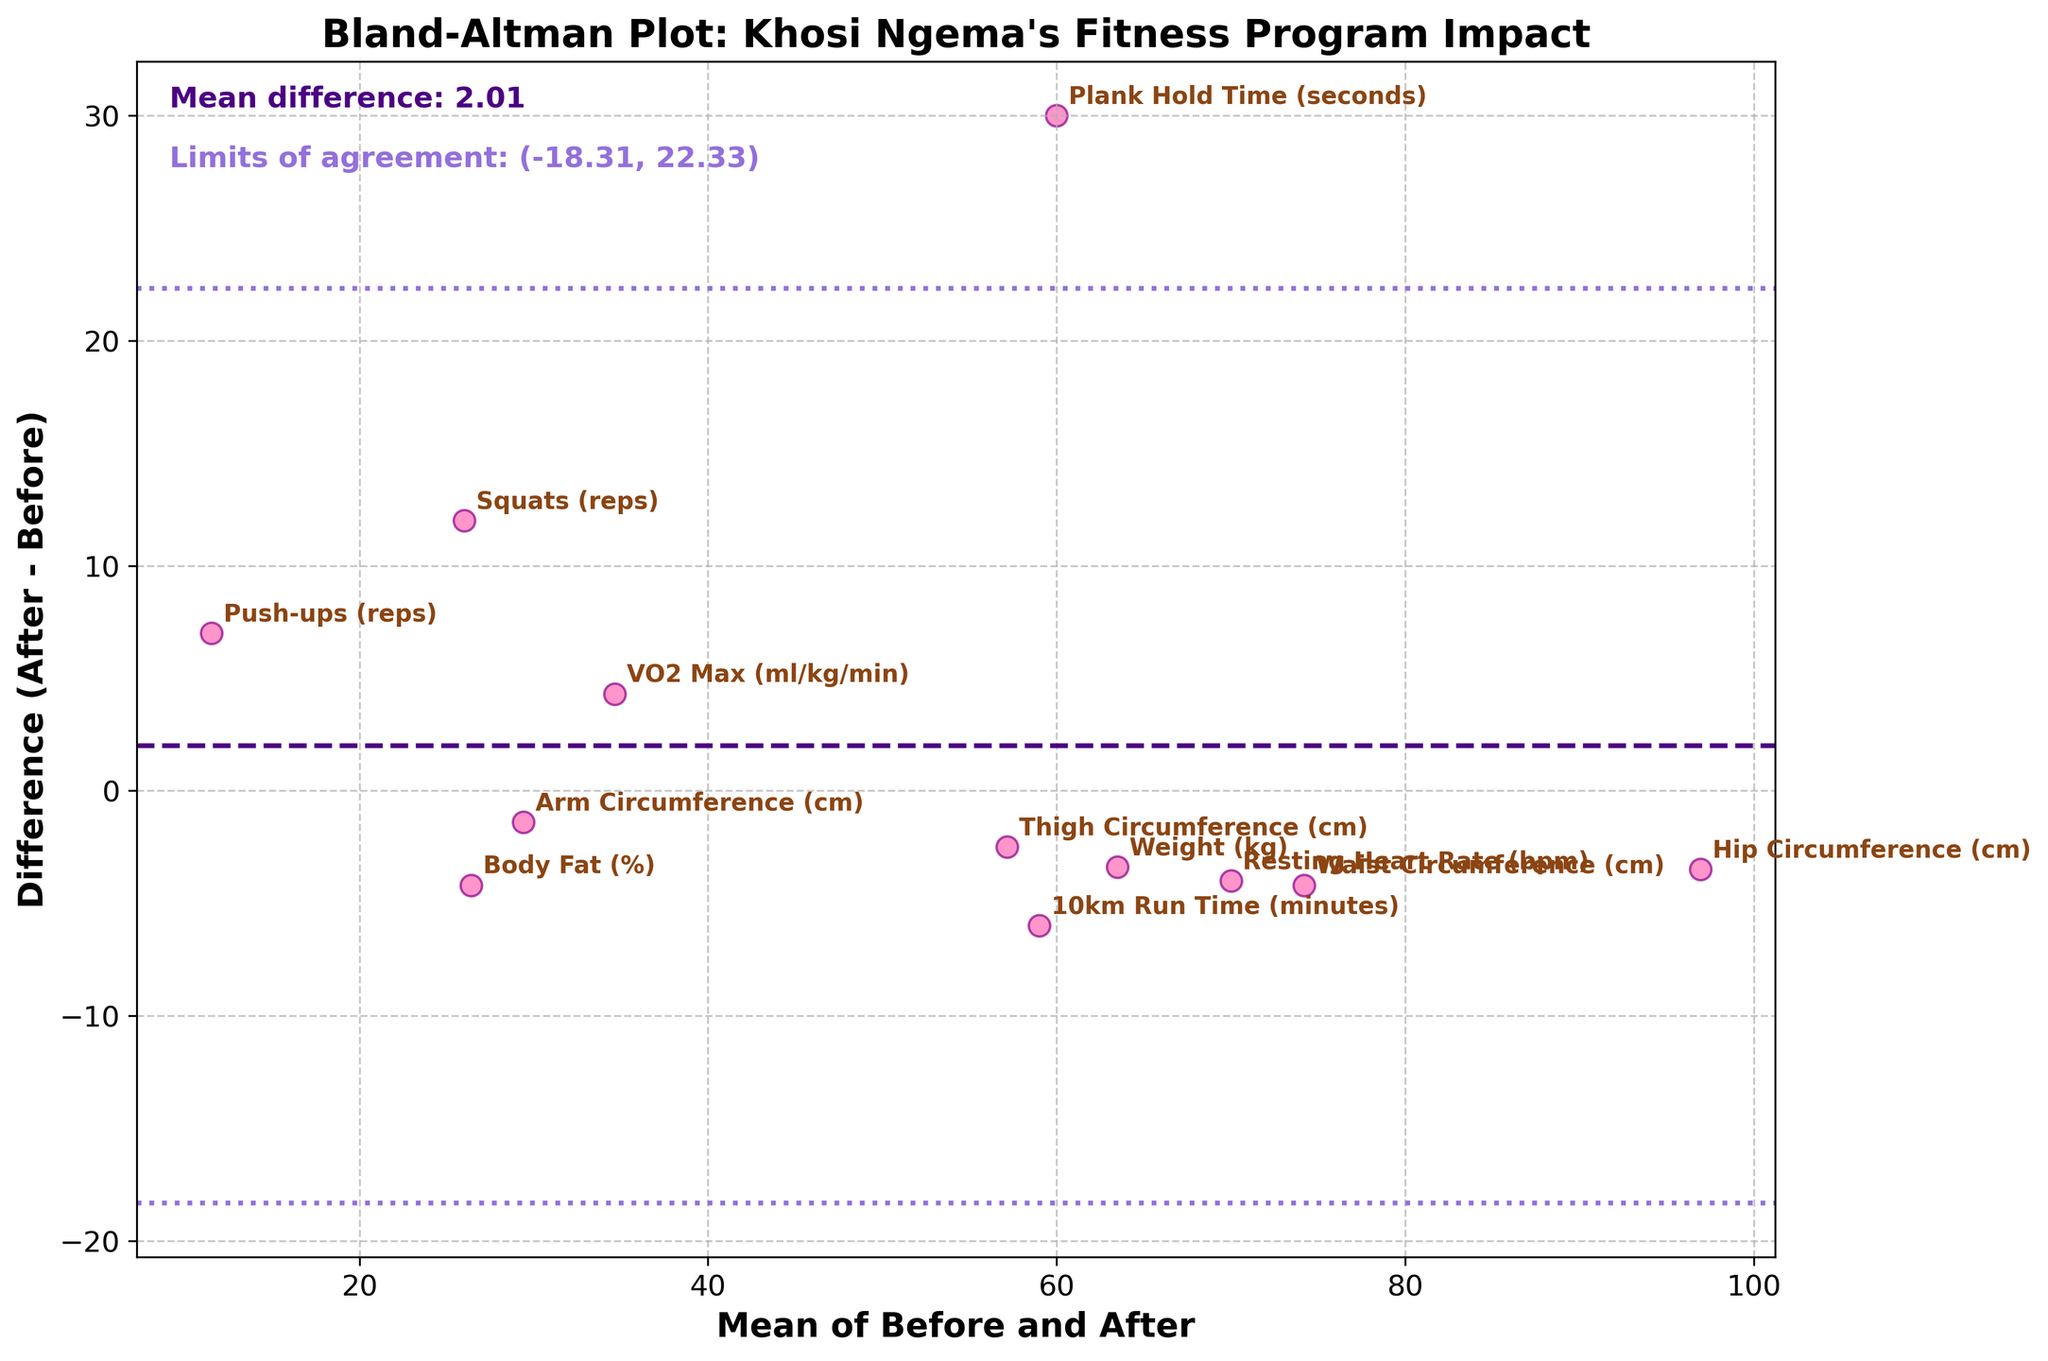What is the title of the plot? The plot's title is usually found at the top of the figure. In this case, it reads "Bland-Altman Plot: Khosi Ngema's Fitness Program Impact".
Answer: Bland-Altman Plot: Khosi Ngema's Fitness Program Impact How many data points are displayed in the plot? Each data point represents a measurement, and the number of data points corresponds to the number of rows in the data table provided, which equals 12.
Answer: 12 What do the Y-axis and X-axis represent? The Y-axis represents the difference between 'After' and 'Before' measurements, while the X-axis represents the mean of 'Before' and 'After' measurements. This information can be found in the axis labels.
Answer: Y-axis: Difference (After - Before), X-axis: Mean of Before and After Which measurement experienced the most significant positive change after the fitness program? To determine which measurement had the highest positive difference, one needs to look at the highest point along the Y-axis. The measurement label near the highest point can be identified as "Plank Hold Time (seconds)".
Answer: Plank Hold Time (seconds) What is the mean difference and how is it visually represented in the plot? The mean difference is the average of all the differences between 'After' and 'Before' measurements. It is represented by a dashed horizontal line, and its value is annotated as "Mean difference: 1.87" on the plot.
Answer: 1.87 How are the limits of agreement represented, and what are their values? The limits of agreement are shown as dotted horizontal lines on the plot. Their values are annotated in the plot as "Limits of agreement: (-13.23, 16.97)".
Answer: (-13.23, 16.97) Which data point lies closest to the mean difference line? To find the closest data point to the mean difference line, look for the data point nearest to the dashed horizontal line in the middle of the plot. This is "VO2 Max (ml/kg/min)".
Answer: VO2 Max (ml/kg/min) How much has the resting heart rate changed after the fitness program? From the plot, the "Resting Heart Rate (bpm)" label corresponds with a point that is positioned lower along the Y-axis. This denotes a negative change, where the difference (after - before) would be -4 bpm.
Answer: -4 bpm Which measurement had a mean of 62 kg, and what was its difference? By identifying the dot located at the mean value of 62 on the X-axis and looking at the associated label, we find that the "Weight (kg)" value has a mean of 62, with a difference of -3.4 kg (from 65.2 to 61.8).
Answer: Weight (kg), -3.4 kg 